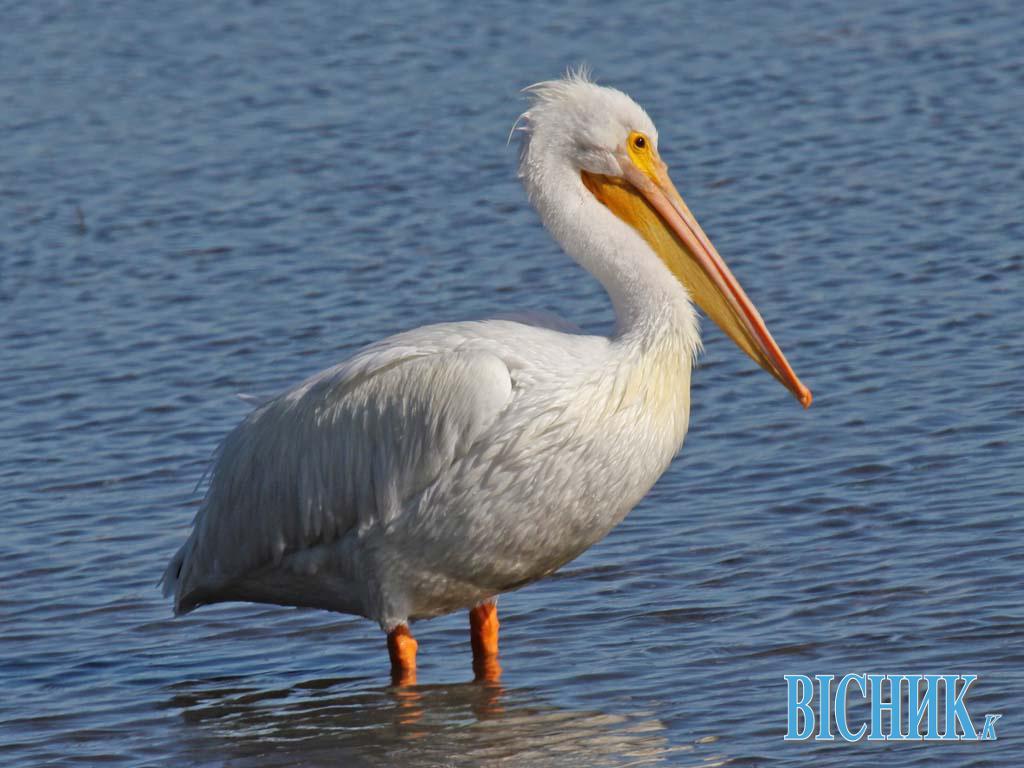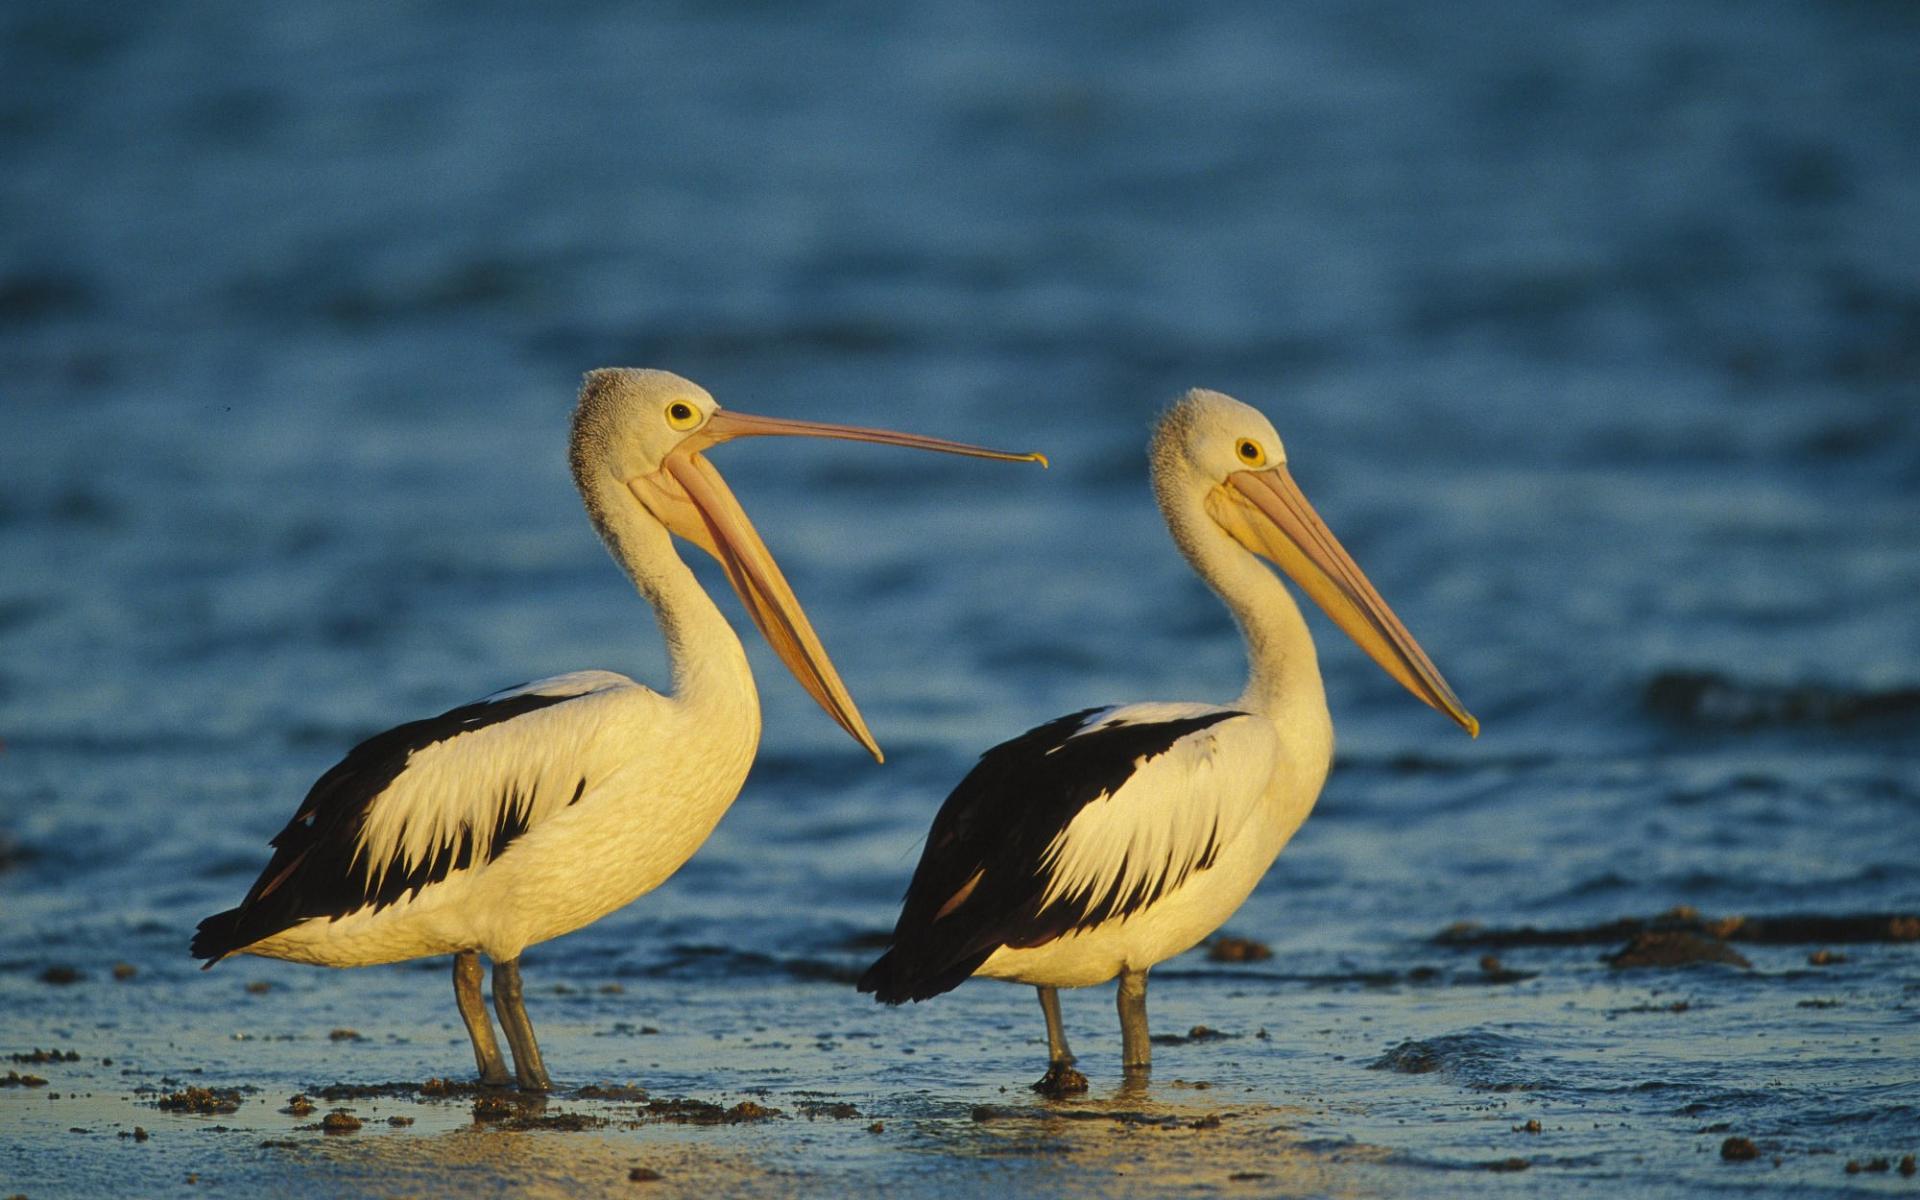The first image is the image on the left, the second image is the image on the right. For the images displayed, is the sentence "All of the birds are facing the right." factually correct? Answer yes or no. Yes. 